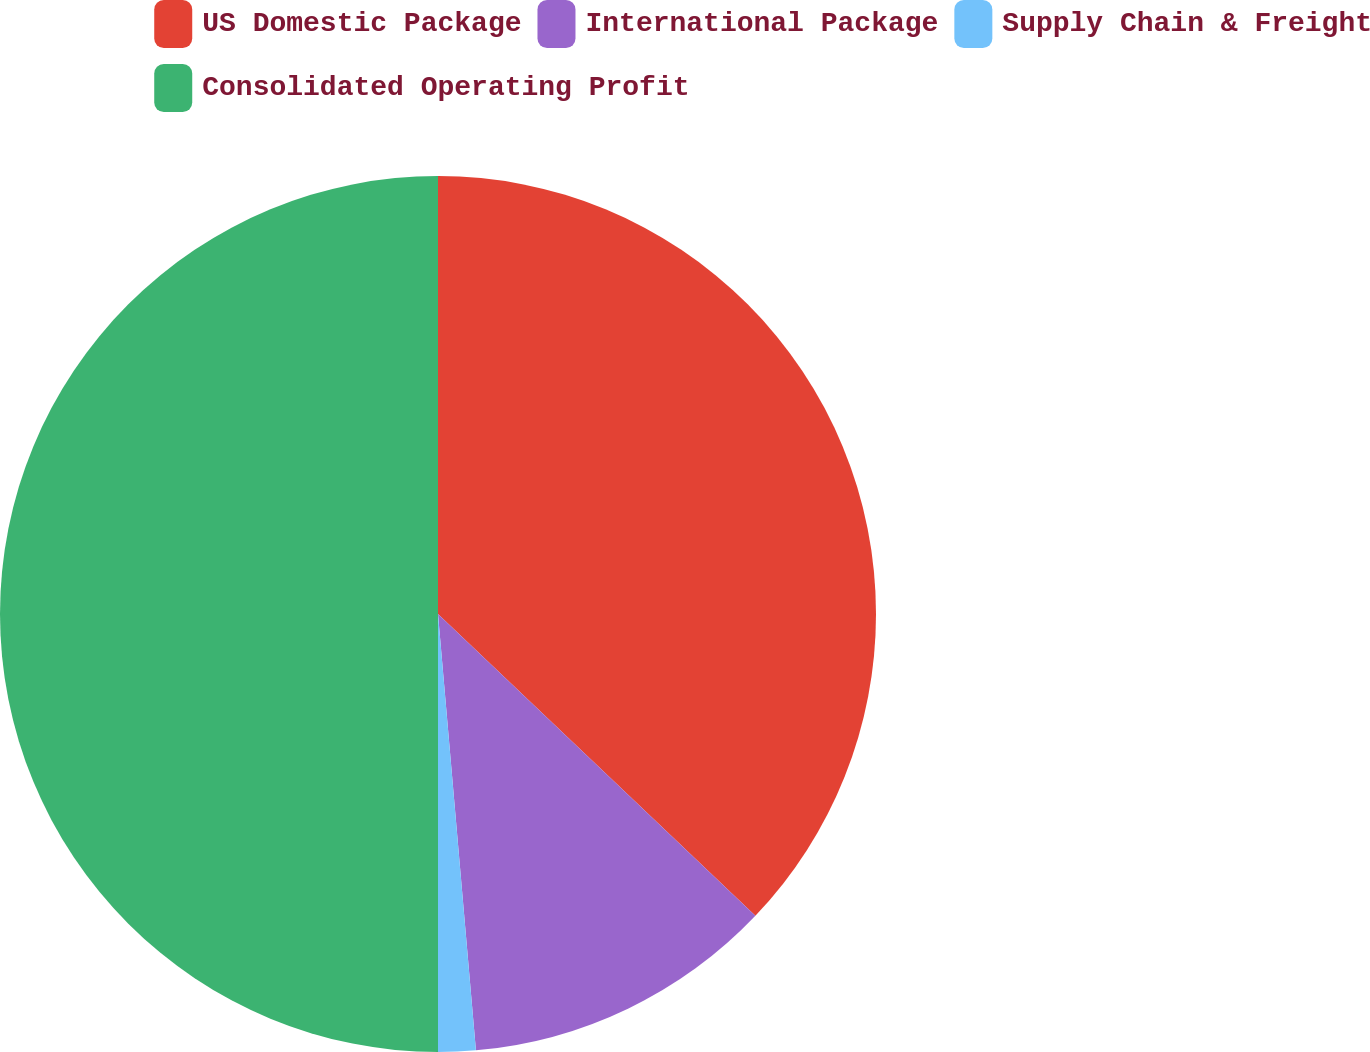Convert chart. <chart><loc_0><loc_0><loc_500><loc_500><pie_chart><fcel>US Domestic Package<fcel>International Package<fcel>Supply Chain & Freight<fcel>Consolidated Operating Profit<nl><fcel>37.1%<fcel>11.52%<fcel>1.38%<fcel>50.0%<nl></chart> 